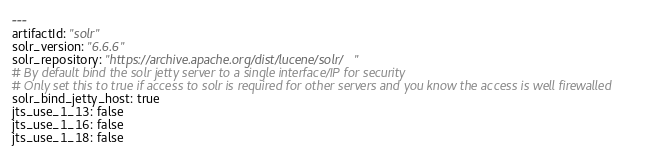<code> <loc_0><loc_0><loc_500><loc_500><_YAML_>---
artifactId: "solr"
solr_version: "6.6.6"
solr_repository: "https://archive.apache.org/dist/lucene/solr/"
# By default bind the solr jetty server to a single interface/IP for security
# Only set this to true if access to solr is required for other servers and you know the access is well firewalled
solr_bind_jetty_host: true
jts_use_1_13: false
jts_use_1_16: false
jts_use_1_18: false
</code> 